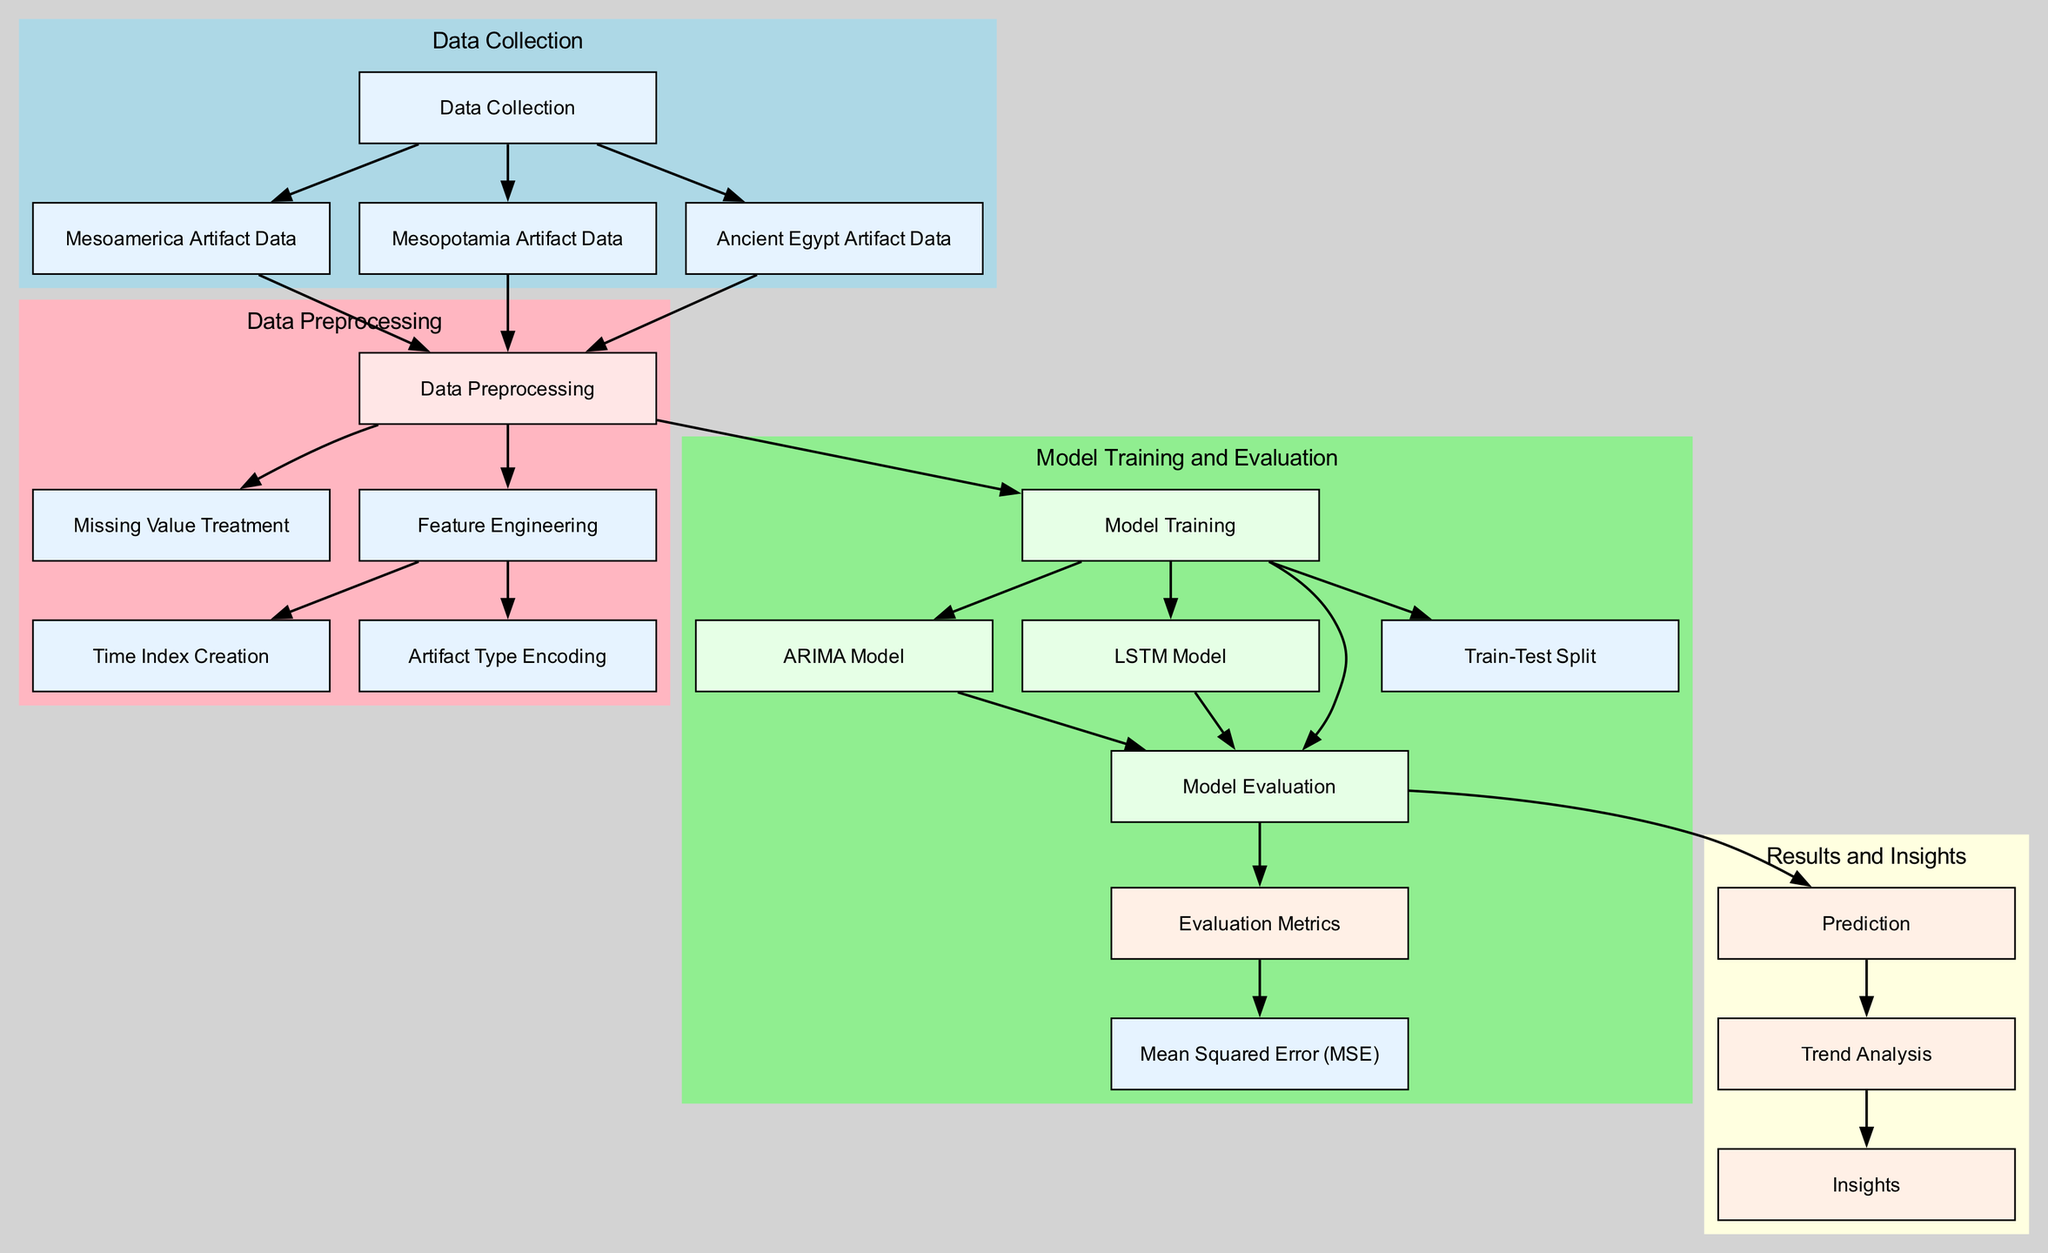What are the three regions represented in the data collection? The diagram indicates three regions: Mesoamerica, Mesopotamia, and Ancient Egypt. These are distinctly labeled in the nodes under the data collection section.
Answer: Mesoamerica, Mesopotamia, Ancient Egypt How many nodes are there in the diagram? Counting all the nodes listed under the various sections of the diagram gives a total of 17 nodes. This includes nodes for data collection, preprocessing, model training, and results.
Answer: 17 What is the last step in the data flow according to the diagram? The final node in the flow after following the edges leads to the insights node, which draws from the trend analysis node. Therefore, the last step in the diagram is insights.
Answer: Insights Which node follows the model evaluation? The model evaluation node has edges leading to two nodes: the evaluation metrics node and the prediction node. However, the immediate next node in the flow, considering it directly follows the model evaluation, is the prediction node.
Answer: Prediction How many edges connect the data preprocessing node? The data preprocessing node has three edges leading to missing value treatment, feature engineering, and model training. Thus, there are a total of three edges connected to it.
Answer: 3 What type of model is represented specifically in the model training section? The model training section includes two specific types of models: the ARIMA model and the LSTM model.
Answer: ARIMA, LSTM What process is conducted before the model training? prior to the model training, the process involves data preprocessing, which includes missing value treatment and feature engineering, among others. Hence, the immediate process before model training is data preprocessing.
Answer: Data preprocessing What metric is associated with the evaluation metrics node? The evaluation metrics node has a direct edge leading to the mean squared error node, indicating that this metric is specifically associated with the evaluation of the models.
Answer: Mean Squared Error Which node contributes to the trend analysis? The trend analysis node receives input from the prediction node, indicating that it is derived directly from the prediction outcomes.
Answer: Prediction 